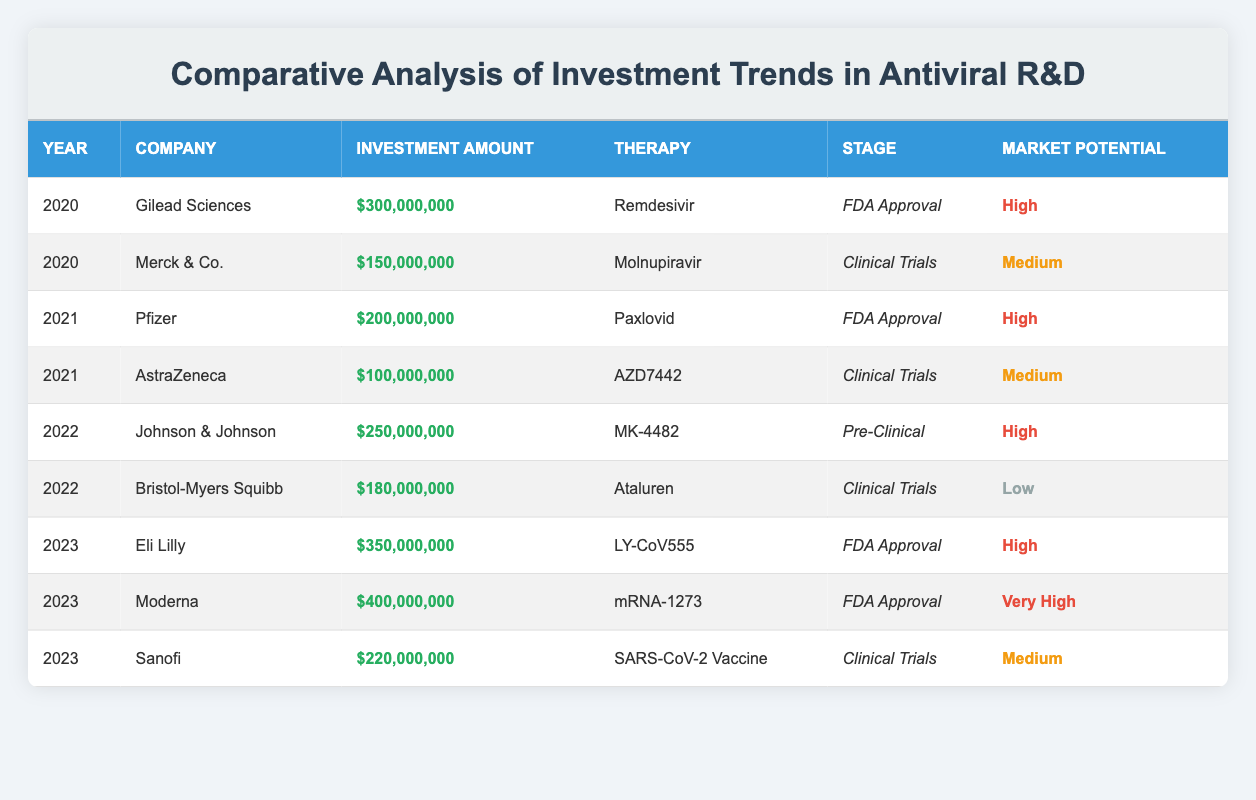What was the total investment amount in antiviral R&D in 2020? The investments in 2020 were $300,000,000 from Gilead Sciences and $150,000,000 from Merck & Co. Adding these amounts together: 300,000,000 + 150,000,000 = 450,000,000
Answer: 450,000,000 Which company invested the most in antiviral therapies in 2023? In 2023, Moderna invested the highest amount, which is $400,000,000. Other companies in 2023 include Eli Lilly with $350,000,000 and Sanofi with $220,000,000, but Moderna has the largest figure.
Answer: Moderna Is the market potential of the therapy "ATALUREN" classified as high? The market potential for ATALUREN, developed by Bristol-Myers Squibb in 2022, is classified as low according to the table. Therefore, this statement is false.
Answer: No What is the average investment amount for antiviral R&D across all years provided in the table? First, sum up the investments: 300,000,000 + 150,000,000 + 200,000,000 + 100,000,000 + 250,000,000 + 180,000,000 + 350,000,000 + 400,000,000 + 220,000,000 =  1,930,000,000. There are 9 data points (years), so the average is 1,930,000,000 / 9 ≈ 214,444,444.44, approximately 214,444,444 when rounded.
Answer: 214,444,444 Has any therapy reached FDA approval more than once in the given years? According to the table, therapies listed for FDA approval include Remdesivir, Paxlovid, LY-CoV555, and mRNA-1273, but each therapy is listed only once for FDA approval. Therefore, this statement is false.
Answer: No Which year had the highest total investment in antiviral R&D? By looking at the investments year-wise in the table: for 2020, total is $450,000,000; for 2021, it is $300,000,000; for 2022, it totals $430,000,000; and for 2023, it's $970,000,000. The highest investment year is 2023 with a total of $970,000,000.
Answer: 2023 